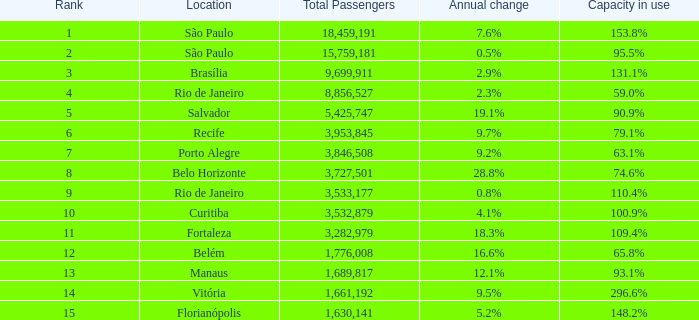What is the highest Total Passengers when the annual change is 18.3%, and the rank is less than 11? None. 